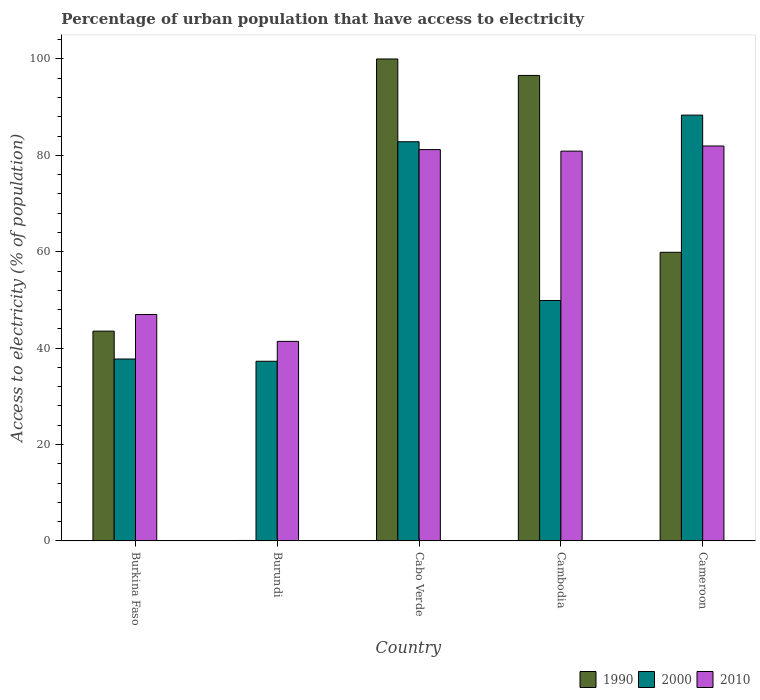How many different coloured bars are there?
Give a very brief answer. 3. Are the number of bars on each tick of the X-axis equal?
Keep it short and to the point. Yes. What is the label of the 4th group of bars from the left?
Provide a succinct answer. Cambodia. In how many cases, is the number of bars for a given country not equal to the number of legend labels?
Keep it short and to the point. 0. What is the percentage of urban population that have access to electricity in 1990 in Burkina Faso?
Make the answer very short. 43.53. Across all countries, what is the maximum percentage of urban population that have access to electricity in 1990?
Make the answer very short. 100. Across all countries, what is the minimum percentage of urban population that have access to electricity in 2000?
Your answer should be compact. 37.28. In which country was the percentage of urban population that have access to electricity in 2010 maximum?
Give a very brief answer. Cameroon. In which country was the percentage of urban population that have access to electricity in 2000 minimum?
Keep it short and to the point. Burundi. What is the total percentage of urban population that have access to electricity in 2010 in the graph?
Provide a succinct answer. 332.41. What is the difference between the percentage of urban population that have access to electricity in 1990 in Burundi and that in Cambodia?
Your response must be concise. -96.48. What is the difference between the percentage of urban population that have access to electricity in 1990 in Cabo Verde and the percentage of urban population that have access to electricity in 2010 in Burkina Faso?
Provide a short and direct response. 53.02. What is the average percentage of urban population that have access to electricity in 2010 per country?
Offer a terse response. 66.48. What is the difference between the percentage of urban population that have access to electricity of/in 2010 and percentage of urban population that have access to electricity of/in 2000 in Cameroon?
Ensure brevity in your answer.  -6.41. In how many countries, is the percentage of urban population that have access to electricity in 2010 greater than 36 %?
Offer a very short reply. 5. What is the ratio of the percentage of urban population that have access to electricity in 2010 in Cambodia to that in Cameroon?
Ensure brevity in your answer.  0.99. Is the percentage of urban population that have access to electricity in 1990 in Burkina Faso less than that in Cambodia?
Ensure brevity in your answer.  Yes. Is the difference between the percentage of urban population that have access to electricity in 2010 in Burundi and Cabo Verde greater than the difference between the percentage of urban population that have access to electricity in 2000 in Burundi and Cabo Verde?
Keep it short and to the point. Yes. What is the difference between the highest and the second highest percentage of urban population that have access to electricity in 1990?
Offer a terse response. 36.7. What is the difference between the highest and the lowest percentage of urban population that have access to electricity in 2010?
Offer a very short reply. 40.54. What does the 2nd bar from the right in Burundi represents?
Your answer should be very brief. 2000. Is it the case that in every country, the sum of the percentage of urban population that have access to electricity in 2000 and percentage of urban population that have access to electricity in 2010 is greater than the percentage of urban population that have access to electricity in 1990?
Offer a very short reply. Yes. Are all the bars in the graph horizontal?
Your answer should be compact. No. How many countries are there in the graph?
Keep it short and to the point. 5. Where does the legend appear in the graph?
Your answer should be very brief. Bottom right. How many legend labels are there?
Your response must be concise. 3. How are the legend labels stacked?
Offer a terse response. Horizontal. What is the title of the graph?
Your answer should be compact. Percentage of urban population that have access to electricity. What is the label or title of the X-axis?
Keep it short and to the point. Country. What is the label or title of the Y-axis?
Make the answer very short. Access to electricity (% of population). What is the Access to electricity (% of population) of 1990 in Burkina Faso?
Keep it short and to the point. 43.53. What is the Access to electricity (% of population) in 2000 in Burkina Faso?
Your response must be concise. 37.75. What is the Access to electricity (% of population) of 2010 in Burkina Faso?
Offer a terse response. 46.98. What is the Access to electricity (% of population) of 1990 in Burundi?
Offer a very short reply. 0.1. What is the Access to electricity (% of population) of 2000 in Burundi?
Provide a succinct answer. 37.28. What is the Access to electricity (% of population) in 2010 in Burundi?
Offer a very short reply. 41.41. What is the Access to electricity (% of population) in 2000 in Cabo Verde?
Your answer should be very brief. 82.83. What is the Access to electricity (% of population) of 2010 in Cabo Verde?
Provide a succinct answer. 81.2. What is the Access to electricity (% of population) of 1990 in Cambodia?
Your answer should be very brief. 96.58. What is the Access to electricity (% of population) of 2000 in Cambodia?
Your response must be concise. 49.89. What is the Access to electricity (% of population) of 2010 in Cambodia?
Your response must be concise. 80.88. What is the Access to electricity (% of population) of 1990 in Cameroon?
Give a very brief answer. 59.89. What is the Access to electricity (% of population) of 2000 in Cameroon?
Your answer should be compact. 88.35. What is the Access to electricity (% of population) of 2010 in Cameroon?
Your response must be concise. 81.95. Across all countries, what is the maximum Access to electricity (% of population) in 1990?
Provide a short and direct response. 100. Across all countries, what is the maximum Access to electricity (% of population) in 2000?
Your answer should be very brief. 88.35. Across all countries, what is the maximum Access to electricity (% of population) of 2010?
Offer a terse response. 81.95. Across all countries, what is the minimum Access to electricity (% of population) in 1990?
Your answer should be compact. 0.1. Across all countries, what is the minimum Access to electricity (% of population) in 2000?
Keep it short and to the point. 37.28. Across all countries, what is the minimum Access to electricity (% of population) of 2010?
Ensure brevity in your answer.  41.41. What is the total Access to electricity (% of population) in 1990 in the graph?
Offer a very short reply. 300.1. What is the total Access to electricity (% of population) in 2000 in the graph?
Your response must be concise. 296.1. What is the total Access to electricity (% of population) of 2010 in the graph?
Ensure brevity in your answer.  332.41. What is the difference between the Access to electricity (% of population) of 1990 in Burkina Faso and that in Burundi?
Your answer should be very brief. 43.43. What is the difference between the Access to electricity (% of population) of 2000 in Burkina Faso and that in Burundi?
Give a very brief answer. 0.47. What is the difference between the Access to electricity (% of population) of 2010 in Burkina Faso and that in Burundi?
Provide a succinct answer. 5.58. What is the difference between the Access to electricity (% of population) in 1990 in Burkina Faso and that in Cabo Verde?
Keep it short and to the point. -56.47. What is the difference between the Access to electricity (% of population) in 2000 in Burkina Faso and that in Cabo Verde?
Offer a very short reply. -45.08. What is the difference between the Access to electricity (% of population) in 2010 in Burkina Faso and that in Cabo Verde?
Provide a short and direct response. -34.21. What is the difference between the Access to electricity (% of population) in 1990 in Burkina Faso and that in Cambodia?
Give a very brief answer. -53.05. What is the difference between the Access to electricity (% of population) in 2000 in Burkina Faso and that in Cambodia?
Your answer should be compact. -12.14. What is the difference between the Access to electricity (% of population) in 2010 in Burkina Faso and that in Cambodia?
Offer a terse response. -33.89. What is the difference between the Access to electricity (% of population) in 1990 in Burkina Faso and that in Cameroon?
Keep it short and to the point. -16.36. What is the difference between the Access to electricity (% of population) of 2000 in Burkina Faso and that in Cameroon?
Your response must be concise. -50.6. What is the difference between the Access to electricity (% of population) of 2010 in Burkina Faso and that in Cameroon?
Your answer should be compact. -34.96. What is the difference between the Access to electricity (% of population) in 1990 in Burundi and that in Cabo Verde?
Your response must be concise. -99.9. What is the difference between the Access to electricity (% of population) in 2000 in Burundi and that in Cabo Verde?
Make the answer very short. -45.54. What is the difference between the Access to electricity (% of population) in 2010 in Burundi and that in Cabo Verde?
Your response must be concise. -39.79. What is the difference between the Access to electricity (% of population) in 1990 in Burundi and that in Cambodia?
Your response must be concise. -96.48. What is the difference between the Access to electricity (% of population) of 2000 in Burundi and that in Cambodia?
Provide a short and direct response. -12.61. What is the difference between the Access to electricity (% of population) in 2010 in Burundi and that in Cambodia?
Provide a short and direct response. -39.47. What is the difference between the Access to electricity (% of population) of 1990 in Burundi and that in Cameroon?
Offer a terse response. -59.79. What is the difference between the Access to electricity (% of population) of 2000 in Burundi and that in Cameroon?
Offer a terse response. -51.07. What is the difference between the Access to electricity (% of population) of 2010 in Burundi and that in Cameroon?
Give a very brief answer. -40.54. What is the difference between the Access to electricity (% of population) in 1990 in Cabo Verde and that in Cambodia?
Provide a succinct answer. 3.42. What is the difference between the Access to electricity (% of population) of 2000 in Cabo Verde and that in Cambodia?
Your answer should be very brief. 32.93. What is the difference between the Access to electricity (% of population) of 2010 in Cabo Verde and that in Cambodia?
Your answer should be compact. 0.32. What is the difference between the Access to electricity (% of population) of 1990 in Cabo Verde and that in Cameroon?
Offer a terse response. 40.11. What is the difference between the Access to electricity (% of population) in 2000 in Cabo Verde and that in Cameroon?
Your answer should be very brief. -5.52. What is the difference between the Access to electricity (% of population) of 2010 in Cabo Verde and that in Cameroon?
Offer a terse response. -0.75. What is the difference between the Access to electricity (% of population) of 1990 in Cambodia and that in Cameroon?
Offer a terse response. 36.7. What is the difference between the Access to electricity (% of population) in 2000 in Cambodia and that in Cameroon?
Your answer should be very brief. -38.46. What is the difference between the Access to electricity (% of population) in 2010 in Cambodia and that in Cameroon?
Ensure brevity in your answer.  -1.07. What is the difference between the Access to electricity (% of population) in 1990 in Burkina Faso and the Access to electricity (% of population) in 2000 in Burundi?
Provide a short and direct response. 6.25. What is the difference between the Access to electricity (% of population) of 1990 in Burkina Faso and the Access to electricity (% of population) of 2010 in Burundi?
Your answer should be very brief. 2.13. What is the difference between the Access to electricity (% of population) in 2000 in Burkina Faso and the Access to electricity (% of population) in 2010 in Burundi?
Keep it short and to the point. -3.66. What is the difference between the Access to electricity (% of population) of 1990 in Burkina Faso and the Access to electricity (% of population) of 2000 in Cabo Verde?
Your answer should be compact. -39.29. What is the difference between the Access to electricity (% of population) of 1990 in Burkina Faso and the Access to electricity (% of population) of 2010 in Cabo Verde?
Offer a very short reply. -37.67. What is the difference between the Access to electricity (% of population) of 2000 in Burkina Faso and the Access to electricity (% of population) of 2010 in Cabo Verde?
Keep it short and to the point. -43.45. What is the difference between the Access to electricity (% of population) in 1990 in Burkina Faso and the Access to electricity (% of population) in 2000 in Cambodia?
Ensure brevity in your answer.  -6.36. What is the difference between the Access to electricity (% of population) of 1990 in Burkina Faso and the Access to electricity (% of population) of 2010 in Cambodia?
Your response must be concise. -37.35. What is the difference between the Access to electricity (% of population) of 2000 in Burkina Faso and the Access to electricity (% of population) of 2010 in Cambodia?
Keep it short and to the point. -43.13. What is the difference between the Access to electricity (% of population) in 1990 in Burkina Faso and the Access to electricity (% of population) in 2000 in Cameroon?
Provide a short and direct response. -44.82. What is the difference between the Access to electricity (% of population) of 1990 in Burkina Faso and the Access to electricity (% of population) of 2010 in Cameroon?
Keep it short and to the point. -38.41. What is the difference between the Access to electricity (% of population) of 2000 in Burkina Faso and the Access to electricity (% of population) of 2010 in Cameroon?
Offer a very short reply. -44.2. What is the difference between the Access to electricity (% of population) of 1990 in Burundi and the Access to electricity (% of population) of 2000 in Cabo Verde?
Give a very brief answer. -82.73. What is the difference between the Access to electricity (% of population) of 1990 in Burundi and the Access to electricity (% of population) of 2010 in Cabo Verde?
Offer a very short reply. -81.1. What is the difference between the Access to electricity (% of population) of 2000 in Burundi and the Access to electricity (% of population) of 2010 in Cabo Verde?
Offer a very short reply. -43.92. What is the difference between the Access to electricity (% of population) in 1990 in Burundi and the Access to electricity (% of population) in 2000 in Cambodia?
Keep it short and to the point. -49.79. What is the difference between the Access to electricity (% of population) of 1990 in Burundi and the Access to electricity (% of population) of 2010 in Cambodia?
Offer a terse response. -80.78. What is the difference between the Access to electricity (% of population) in 2000 in Burundi and the Access to electricity (% of population) in 2010 in Cambodia?
Your answer should be compact. -43.6. What is the difference between the Access to electricity (% of population) in 1990 in Burundi and the Access to electricity (% of population) in 2000 in Cameroon?
Your answer should be very brief. -88.25. What is the difference between the Access to electricity (% of population) of 1990 in Burundi and the Access to electricity (% of population) of 2010 in Cameroon?
Offer a terse response. -81.85. What is the difference between the Access to electricity (% of population) of 2000 in Burundi and the Access to electricity (% of population) of 2010 in Cameroon?
Keep it short and to the point. -44.66. What is the difference between the Access to electricity (% of population) of 1990 in Cabo Verde and the Access to electricity (% of population) of 2000 in Cambodia?
Provide a short and direct response. 50.11. What is the difference between the Access to electricity (% of population) in 1990 in Cabo Verde and the Access to electricity (% of population) in 2010 in Cambodia?
Ensure brevity in your answer.  19.12. What is the difference between the Access to electricity (% of population) of 2000 in Cabo Verde and the Access to electricity (% of population) of 2010 in Cambodia?
Your answer should be very brief. 1.95. What is the difference between the Access to electricity (% of population) of 1990 in Cabo Verde and the Access to electricity (% of population) of 2000 in Cameroon?
Keep it short and to the point. 11.65. What is the difference between the Access to electricity (% of population) of 1990 in Cabo Verde and the Access to electricity (% of population) of 2010 in Cameroon?
Provide a succinct answer. 18.05. What is the difference between the Access to electricity (% of population) in 2000 in Cabo Verde and the Access to electricity (% of population) in 2010 in Cameroon?
Make the answer very short. 0.88. What is the difference between the Access to electricity (% of population) of 1990 in Cambodia and the Access to electricity (% of population) of 2000 in Cameroon?
Ensure brevity in your answer.  8.23. What is the difference between the Access to electricity (% of population) of 1990 in Cambodia and the Access to electricity (% of population) of 2010 in Cameroon?
Your answer should be compact. 14.64. What is the difference between the Access to electricity (% of population) in 2000 in Cambodia and the Access to electricity (% of population) in 2010 in Cameroon?
Ensure brevity in your answer.  -32.05. What is the average Access to electricity (% of population) in 1990 per country?
Keep it short and to the point. 60.02. What is the average Access to electricity (% of population) in 2000 per country?
Provide a short and direct response. 59.22. What is the average Access to electricity (% of population) of 2010 per country?
Your answer should be compact. 66.48. What is the difference between the Access to electricity (% of population) in 1990 and Access to electricity (% of population) in 2000 in Burkina Faso?
Keep it short and to the point. 5.78. What is the difference between the Access to electricity (% of population) of 1990 and Access to electricity (% of population) of 2010 in Burkina Faso?
Make the answer very short. -3.45. What is the difference between the Access to electricity (% of population) of 2000 and Access to electricity (% of population) of 2010 in Burkina Faso?
Offer a very short reply. -9.24. What is the difference between the Access to electricity (% of population) in 1990 and Access to electricity (% of population) in 2000 in Burundi?
Your response must be concise. -37.18. What is the difference between the Access to electricity (% of population) of 1990 and Access to electricity (% of population) of 2010 in Burundi?
Make the answer very short. -41.31. What is the difference between the Access to electricity (% of population) in 2000 and Access to electricity (% of population) in 2010 in Burundi?
Keep it short and to the point. -4.12. What is the difference between the Access to electricity (% of population) of 1990 and Access to electricity (% of population) of 2000 in Cabo Verde?
Ensure brevity in your answer.  17.17. What is the difference between the Access to electricity (% of population) of 1990 and Access to electricity (% of population) of 2010 in Cabo Verde?
Make the answer very short. 18.8. What is the difference between the Access to electricity (% of population) in 2000 and Access to electricity (% of population) in 2010 in Cabo Verde?
Your answer should be very brief. 1.63. What is the difference between the Access to electricity (% of population) of 1990 and Access to electricity (% of population) of 2000 in Cambodia?
Provide a short and direct response. 46.69. What is the difference between the Access to electricity (% of population) in 1990 and Access to electricity (% of population) in 2010 in Cambodia?
Ensure brevity in your answer.  15.71. What is the difference between the Access to electricity (% of population) in 2000 and Access to electricity (% of population) in 2010 in Cambodia?
Offer a terse response. -30.99. What is the difference between the Access to electricity (% of population) of 1990 and Access to electricity (% of population) of 2000 in Cameroon?
Provide a succinct answer. -28.46. What is the difference between the Access to electricity (% of population) in 1990 and Access to electricity (% of population) in 2010 in Cameroon?
Offer a terse response. -22.06. What is the difference between the Access to electricity (% of population) of 2000 and Access to electricity (% of population) of 2010 in Cameroon?
Provide a short and direct response. 6.41. What is the ratio of the Access to electricity (% of population) in 1990 in Burkina Faso to that in Burundi?
Your response must be concise. 435.31. What is the ratio of the Access to electricity (% of population) of 2000 in Burkina Faso to that in Burundi?
Provide a short and direct response. 1.01. What is the ratio of the Access to electricity (% of population) of 2010 in Burkina Faso to that in Burundi?
Give a very brief answer. 1.13. What is the ratio of the Access to electricity (% of population) in 1990 in Burkina Faso to that in Cabo Verde?
Offer a very short reply. 0.44. What is the ratio of the Access to electricity (% of population) in 2000 in Burkina Faso to that in Cabo Verde?
Provide a succinct answer. 0.46. What is the ratio of the Access to electricity (% of population) of 2010 in Burkina Faso to that in Cabo Verde?
Keep it short and to the point. 0.58. What is the ratio of the Access to electricity (% of population) in 1990 in Burkina Faso to that in Cambodia?
Ensure brevity in your answer.  0.45. What is the ratio of the Access to electricity (% of population) in 2000 in Burkina Faso to that in Cambodia?
Your answer should be compact. 0.76. What is the ratio of the Access to electricity (% of population) in 2010 in Burkina Faso to that in Cambodia?
Provide a succinct answer. 0.58. What is the ratio of the Access to electricity (% of population) of 1990 in Burkina Faso to that in Cameroon?
Keep it short and to the point. 0.73. What is the ratio of the Access to electricity (% of population) in 2000 in Burkina Faso to that in Cameroon?
Give a very brief answer. 0.43. What is the ratio of the Access to electricity (% of population) in 2010 in Burkina Faso to that in Cameroon?
Provide a succinct answer. 0.57. What is the ratio of the Access to electricity (% of population) in 1990 in Burundi to that in Cabo Verde?
Make the answer very short. 0. What is the ratio of the Access to electricity (% of population) of 2000 in Burundi to that in Cabo Verde?
Make the answer very short. 0.45. What is the ratio of the Access to electricity (% of population) in 2010 in Burundi to that in Cabo Verde?
Make the answer very short. 0.51. What is the ratio of the Access to electricity (% of population) in 1990 in Burundi to that in Cambodia?
Make the answer very short. 0. What is the ratio of the Access to electricity (% of population) of 2000 in Burundi to that in Cambodia?
Provide a short and direct response. 0.75. What is the ratio of the Access to electricity (% of population) of 2010 in Burundi to that in Cambodia?
Keep it short and to the point. 0.51. What is the ratio of the Access to electricity (% of population) in 1990 in Burundi to that in Cameroon?
Make the answer very short. 0. What is the ratio of the Access to electricity (% of population) of 2000 in Burundi to that in Cameroon?
Offer a terse response. 0.42. What is the ratio of the Access to electricity (% of population) in 2010 in Burundi to that in Cameroon?
Your answer should be compact. 0.51. What is the ratio of the Access to electricity (% of population) in 1990 in Cabo Verde to that in Cambodia?
Provide a succinct answer. 1.04. What is the ratio of the Access to electricity (% of population) of 2000 in Cabo Verde to that in Cambodia?
Your answer should be very brief. 1.66. What is the ratio of the Access to electricity (% of population) of 2010 in Cabo Verde to that in Cambodia?
Your answer should be compact. 1. What is the ratio of the Access to electricity (% of population) in 1990 in Cabo Verde to that in Cameroon?
Your response must be concise. 1.67. What is the ratio of the Access to electricity (% of population) in 2010 in Cabo Verde to that in Cameroon?
Make the answer very short. 0.99. What is the ratio of the Access to electricity (% of population) of 1990 in Cambodia to that in Cameroon?
Offer a very short reply. 1.61. What is the ratio of the Access to electricity (% of population) in 2000 in Cambodia to that in Cameroon?
Make the answer very short. 0.56. What is the difference between the highest and the second highest Access to electricity (% of population) of 1990?
Keep it short and to the point. 3.42. What is the difference between the highest and the second highest Access to electricity (% of population) in 2000?
Give a very brief answer. 5.52. What is the difference between the highest and the second highest Access to electricity (% of population) in 2010?
Offer a very short reply. 0.75. What is the difference between the highest and the lowest Access to electricity (% of population) in 1990?
Provide a short and direct response. 99.9. What is the difference between the highest and the lowest Access to electricity (% of population) in 2000?
Provide a short and direct response. 51.07. What is the difference between the highest and the lowest Access to electricity (% of population) in 2010?
Your response must be concise. 40.54. 